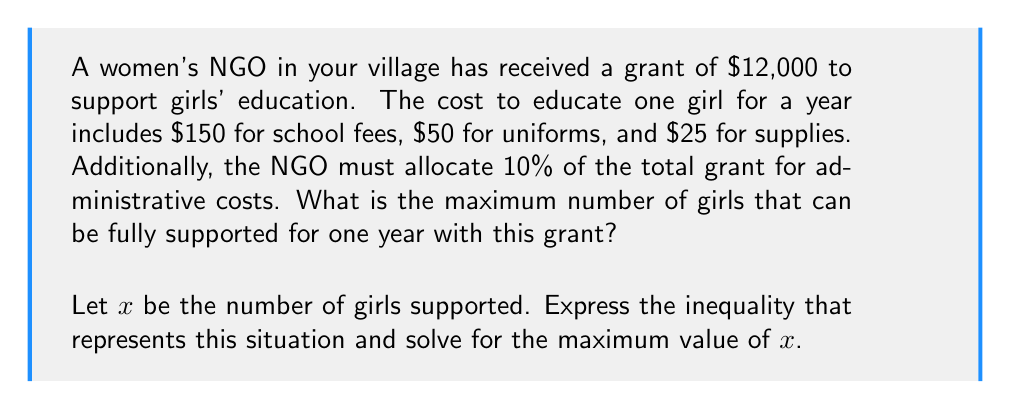Show me your answer to this math problem. Let's approach this step-by-step:

1) First, let's calculate the total cost to educate one girl for a year:
   $150 + $50 + $25 = $225 per girl

2) Now, we need to account for the 10% administrative costs. This means only 90% of the grant is available for direct education costs.
   Available funds = 90% of $12,000 = $0.90 \times $12,000 = $10,800

3) We can now set up our inequality:
   $225x \leq 10800$, where $x$ is the number of girls

4) To solve for $x$, we divide both sides by 225:
   $$\frac{225x}{225} \leq \frac{10800}{225}$$
   $$x \leq 48$$

5) Since $x$ represents the number of girls, it must be a whole number. Therefore, the maximum value for $x$ is 48.

6) Let's verify:
   48 girls: $48 \times $225 = $10,800 (exactly the available funds)
   49 girls: $49 \times $225 = $11,025 (exceeds available funds)

Therefore, the maximum number of girls that can be supported is 48.
Answer: The maximum number of girls that can be fully supported for one year is 48. 